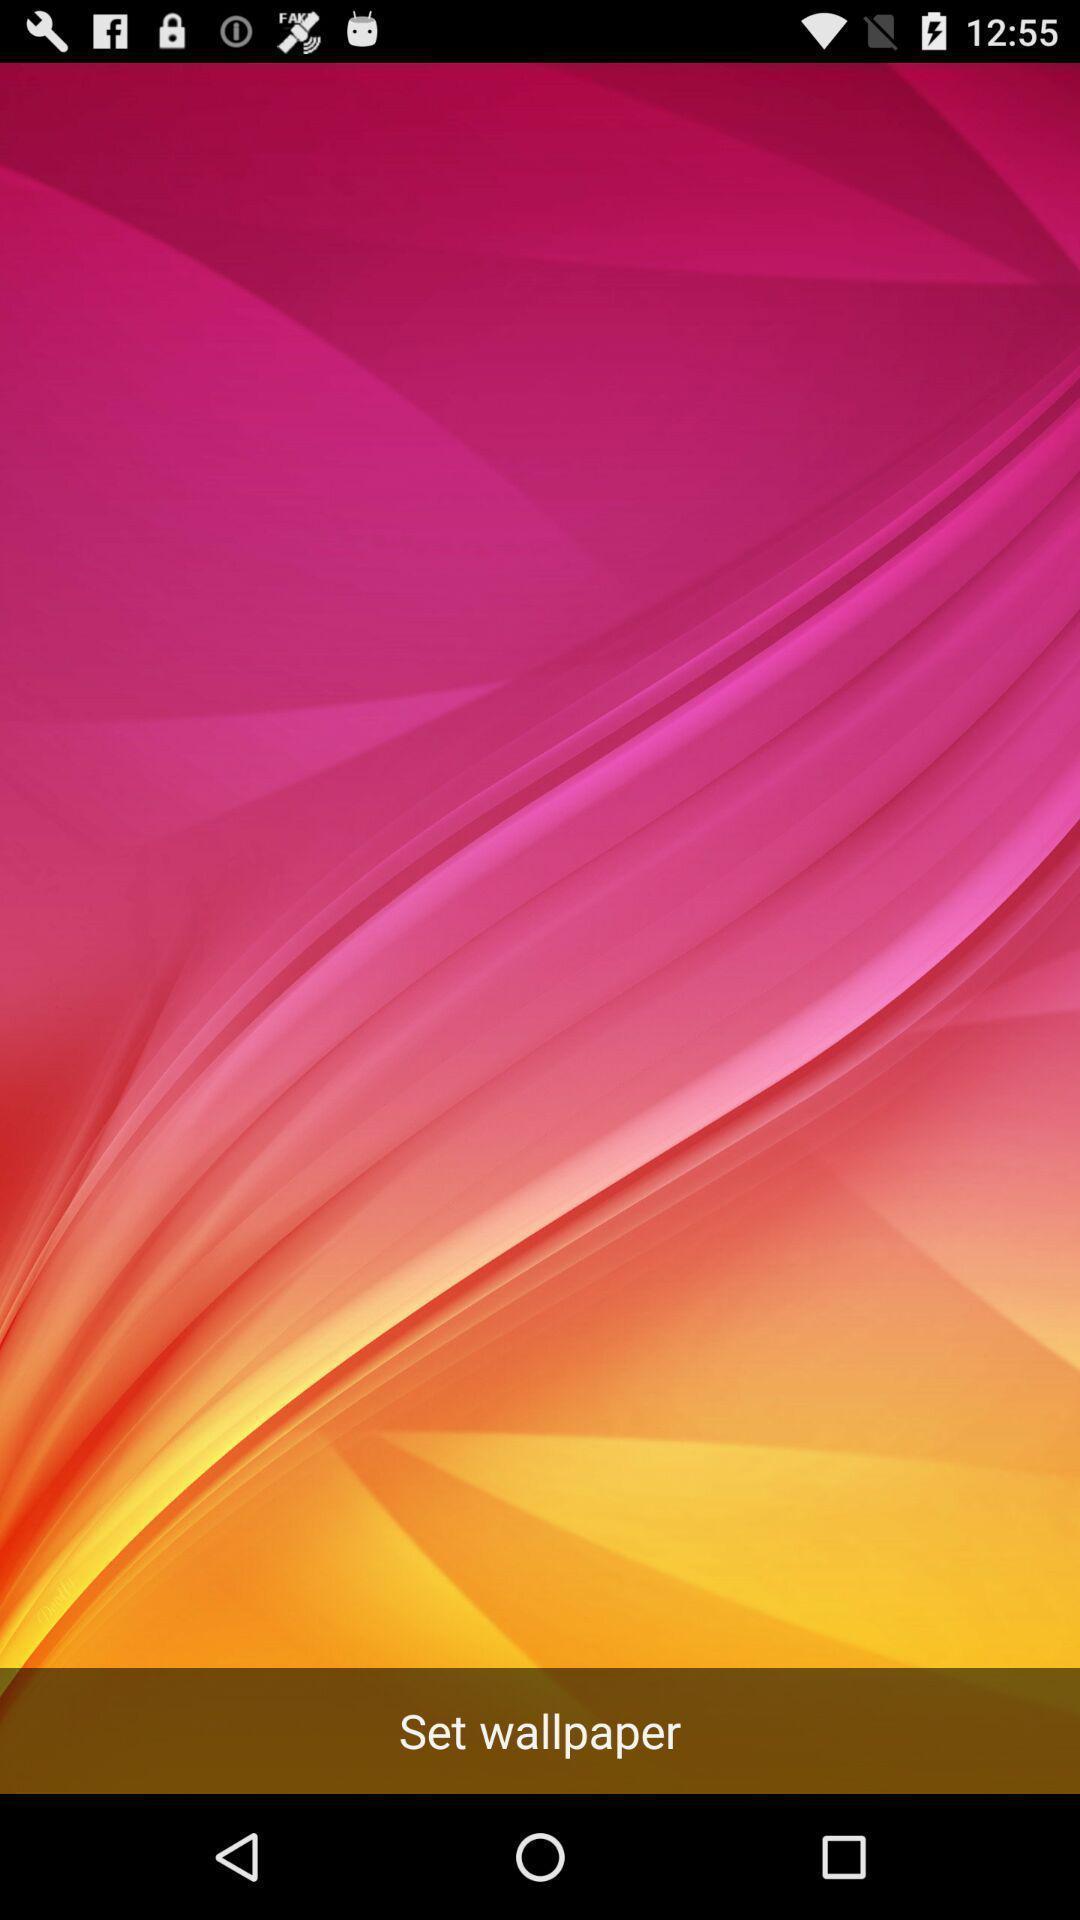Give me a narrative description of this picture. Page for setting a wallpaper of a mobile. 